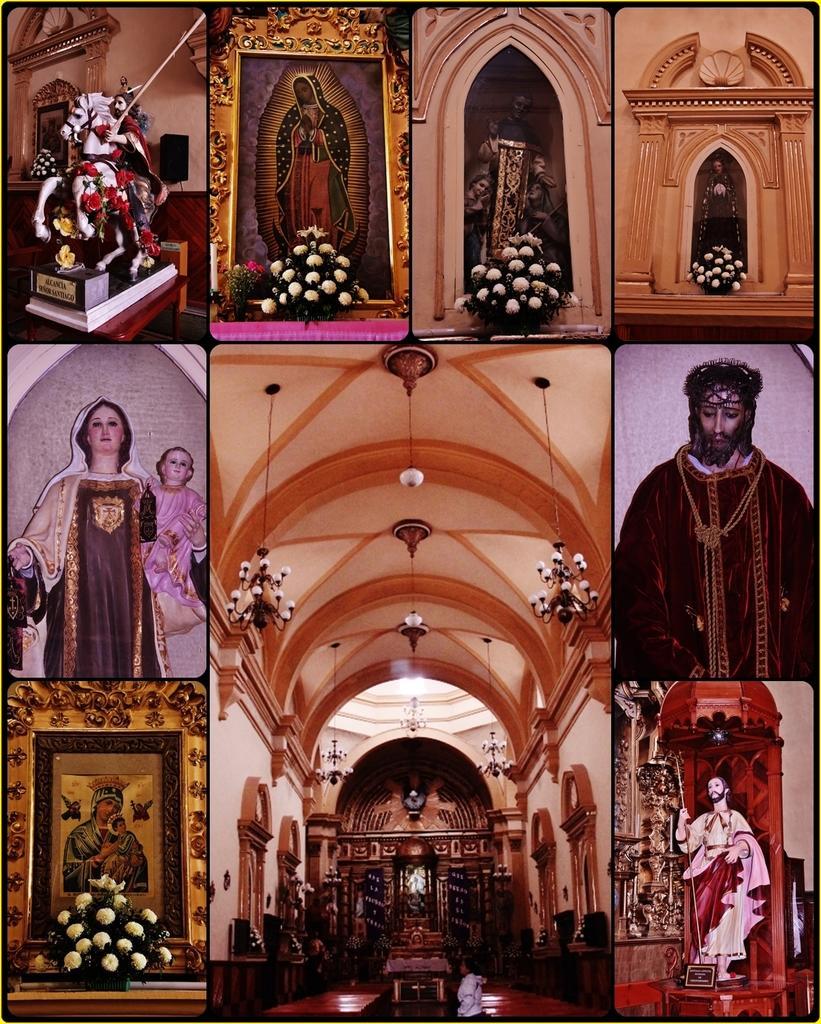What type of artwork is depicted in the image? The image is a collage. What elements can be found within the collage? There are status and photo frames in the collage. Are there any natural elements present in the collage? Yes, there are flowers in the collage. What is the topic of the discussion taking place in the collage? There is no discussion present in the collage; it is a static image composed of various elements. 